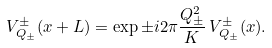<formula> <loc_0><loc_0><loc_500><loc_500>V _ { Q _ { \pm } } ^ { \pm } ( x + L ) = \exp \pm i 2 \pi \frac { Q _ { \pm } ^ { 2 } } { K } \, V _ { Q _ { \pm } } ^ { \pm } ( x ) .</formula> 